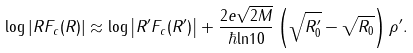Convert formula to latex. <formula><loc_0><loc_0><loc_500><loc_500>\log \left | R F _ { c } ( R ) \right | \approx \log \left | R ^ { \prime } F _ { c } ( R ^ { \prime } ) \right | + \frac { 2 e \sqrt { 2 M } } { \hbar { \ln } 1 0 } \left ( \sqrt { R _ { 0 } ^ { \prime } } - \sqrt { R _ { 0 } } \right ) \rho ^ { \prime } .</formula> 